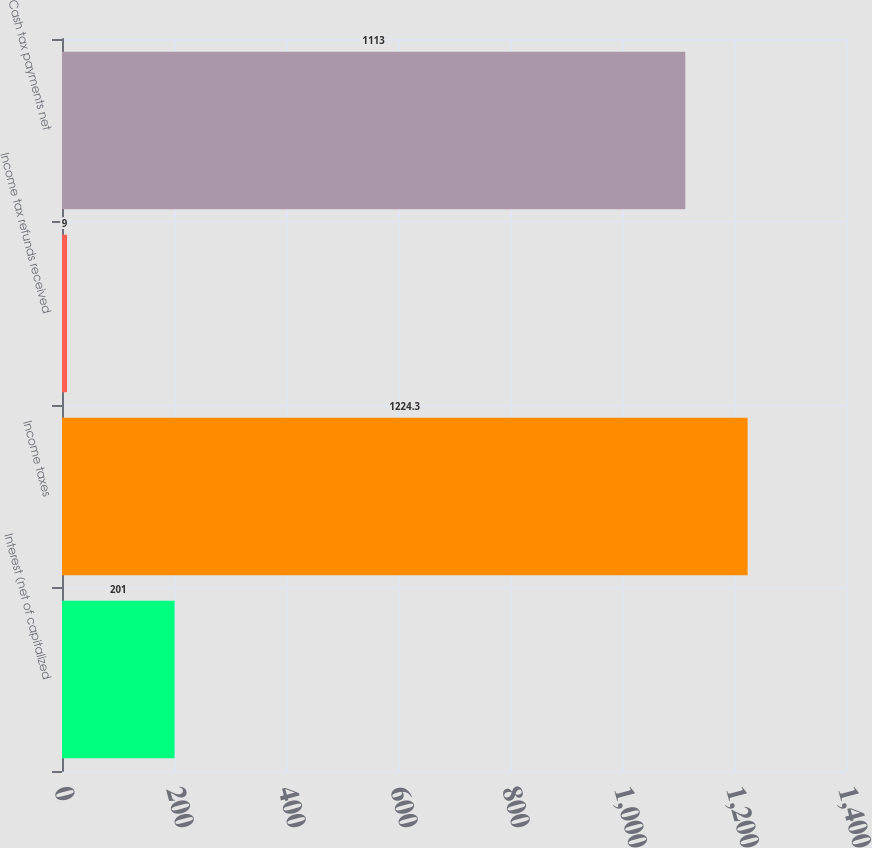Convert chart. <chart><loc_0><loc_0><loc_500><loc_500><bar_chart><fcel>Interest (net of capitalized<fcel>Income taxes<fcel>Income tax refunds received<fcel>Cash tax payments net<nl><fcel>201<fcel>1224.3<fcel>9<fcel>1113<nl></chart> 